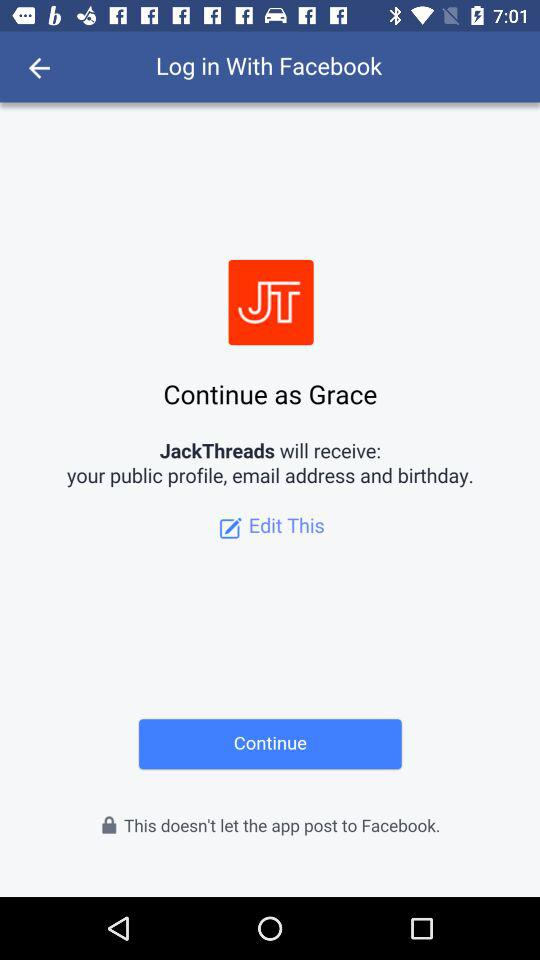What is the user name? The user name is Grace. 